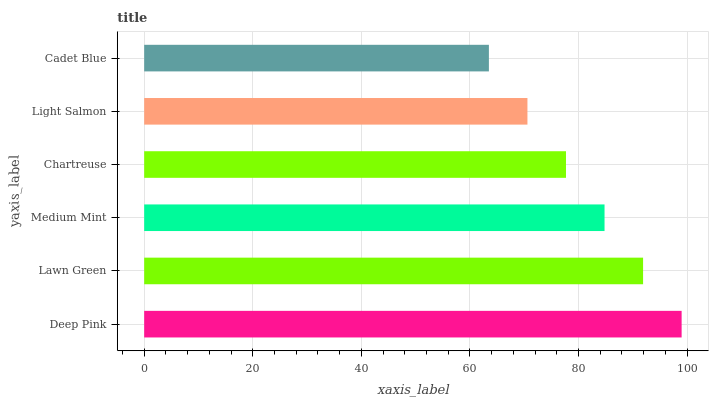Is Cadet Blue the minimum?
Answer yes or no. Yes. Is Deep Pink the maximum?
Answer yes or no. Yes. Is Lawn Green the minimum?
Answer yes or no. No. Is Lawn Green the maximum?
Answer yes or no. No. Is Deep Pink greater than Lawn Green?
Answer yes or no. Yes. Is Lawn Green less than Deep Pink?
Answer yes or no. Yes. Is Lawn Green greater than Deep Pink?
Answer yes or no. No. Is Deep Pink less than Lawn Green?
Answer yes or no. No. Is Medium Mint the high median?
Answer yes or no. Yes. Is Chartreuse the low median?
Answer yes or no. Yes. Is Cadet Blue the high median?
Answer yes or no. No. Is Lawn Green the low median?
Answer yes or no. No. 